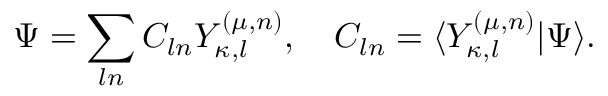<formula> <loc_0><loc_0><loc_500><loc_500>\Psi = \sum _ { \ln } C _ { \ln } Y _ { \kappa , l } ^ { ( \mu , n ) } , \quad C _ { \ln } = \langle Y _ { \kappa , l } ^ { ( \mu , n ) } | \Psi \rangle .</formula> 